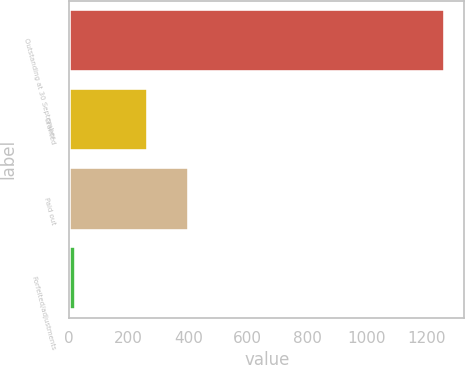Convert chart to OTSL. <chart><loc_0><loc_0><loc_500><loc_500><bar_chart><fcel>Outstanding at 30 September<fcel>Granted<fcel>Paid out<fcel>Forfeited/adjustments<nl><fcel>1264<fcel>264<fcel>403.3<fcel>23<nl></chart> 